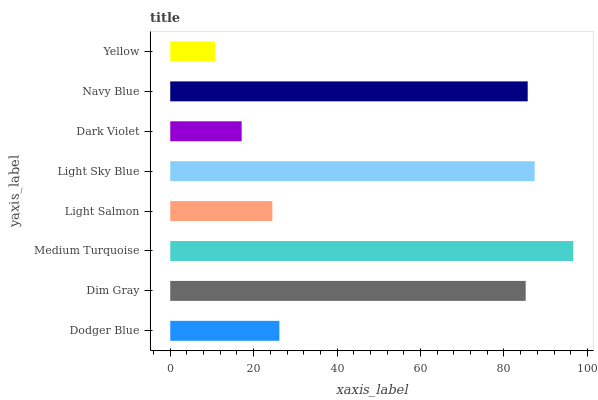Is Yellow the minimum?
Answer yes or no. Yes. Is Medium Turquoise the maximum?
Answer yes or no. Yes. Is Dim Gray the minimum?
Answer yes or no. No. Is Dim Gray the maximum?
Answer yes or no. No. Is Dim Gray greater than Dodger Blue?
Answer yes or no. Yes. Is Dodger Blue less than Dim Gray?
Answer yes or no. Yes. Is Dodger Blue greater than Dim Gray?
Answer yes or no. No. Is Dim Gray less than Dodger Blue?
Answer yes or no. No. Is Dim Gray the high median?
Answer yes or no. Yes. Is Dodger Blue the low median?
Answer yes or no. Yes. Is Dark Violet the high median?
Answer yes or no. No. Is Light Sky Blue the low median?
Answer yes or no. No. 